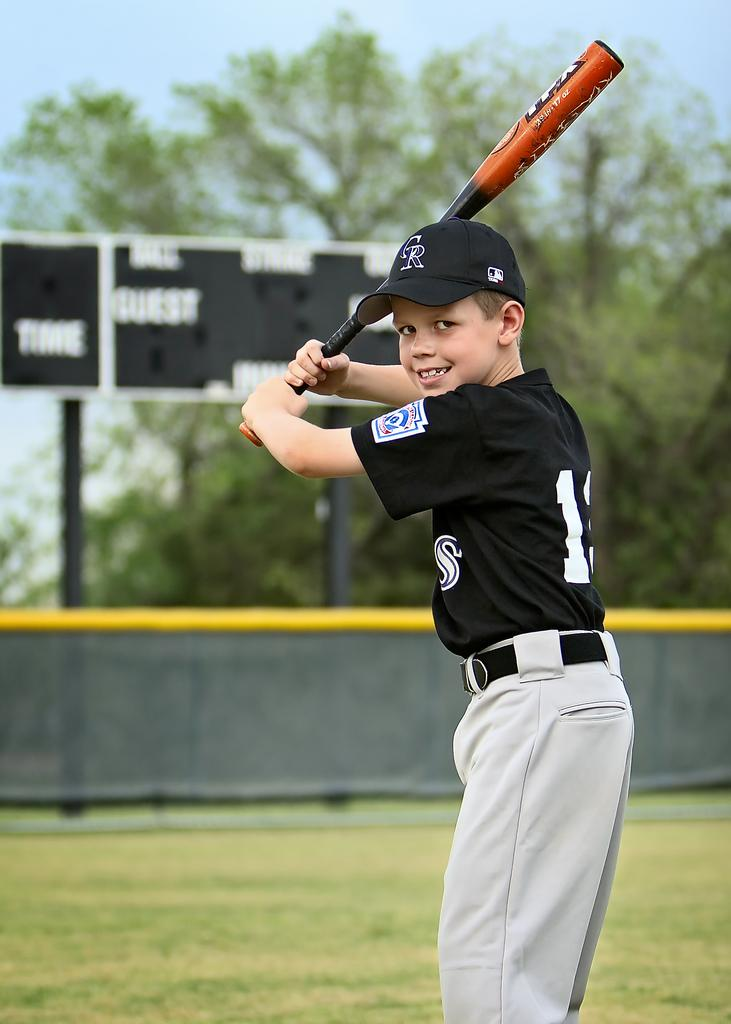<image>
Share a concise interpretation of the image provided. A young boy with the number one on his  jersey is holding a bat. 